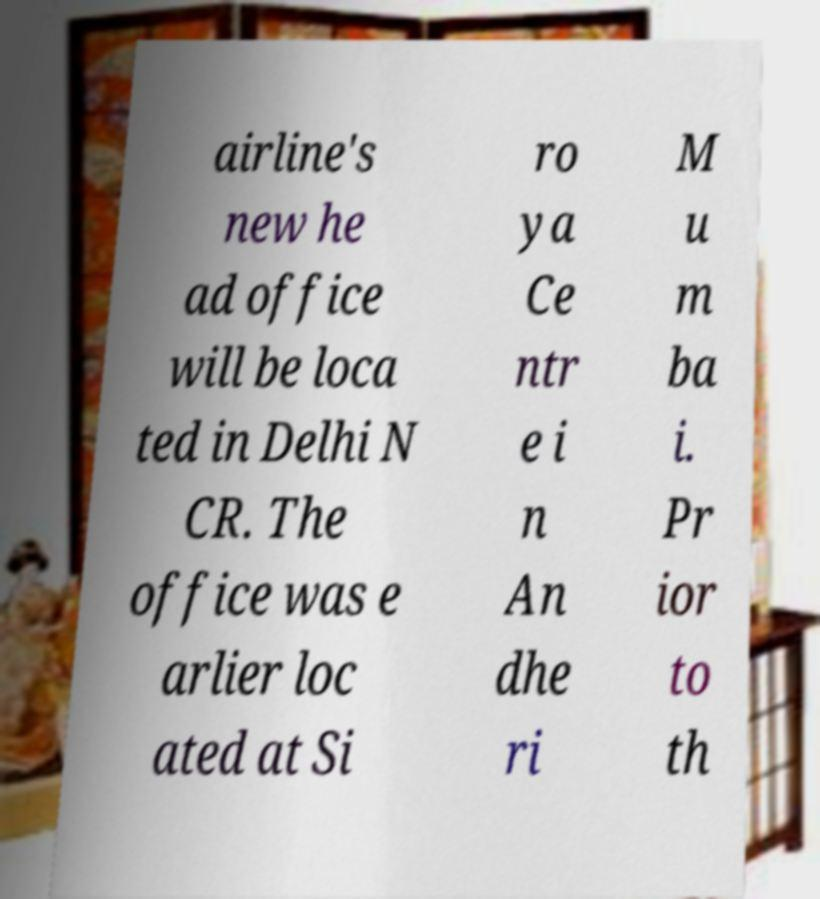Please read and relay the text visible in this image. What does it say? airline's new he ad office will be loca ted in Delhi N CR. The office was e arlier loc ated at Si ro ya Ce ntr e i n An dhe ri M u m ba i. Pr ior to th 